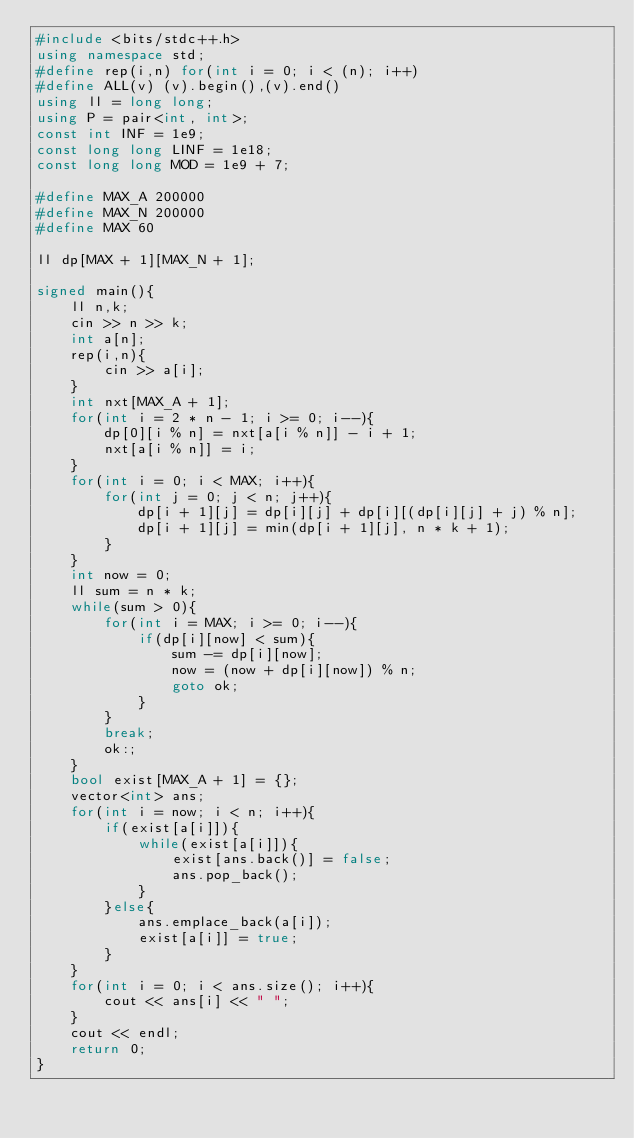Convert code to text. <code><loc_0><loc_0><loc_500><loc_500><_C++_>#include <bits/stdc++.h>
using namespace std;
#define rep(i,n) for(int i = 0; i < (n); i++)
#define ALL(v) (v).begin(),(v).end()
using ll = long long;
using P = pair<int, int>;
const int INF = 1e9;
const long long LINF = 1e18;
const long long MOD = 1e9 + 7;

#define MAX_A 200000
#define MAX_N 200000
#define MAX 60

ll dp[MAX + 1][MAX_N + 1];

signed main(){
    ll n,k;
    cin >> n >> k;
    int a[n];
    rep(i,n){
        cin >> a[i];
    }
    int nxt[MAX_A + 1];
    for(int i = 2 * n - 1; i >= 0; i--){
        dp[0][i % n] = nxt[a[i % n]] - i + 1;
        nxt[a[i % n]] = i;
    }
    for(int i = 0; i < MAX; i++){
        for(int j = 0; j < n; j++){
            dp[i + 1][j] = dp[i][j] + dp[i][(dp[i][j] + j) % n];
            dp[i + 1][j] = min(dp[i + 1][j], n * k + 1);
        }
    }
    int now = 0;
    ll sum = n * k;
    while(sum > 0){
        for(int i = MAX; i >= 0; i--){
            if(dp[i][now] < sum){
                sum -= dp[i][now];
                now = (now + dp[i][now]) % n;
                goto ok;
            }
        }
        break;
        ok:;
    }
    bool exist[MAX_A + 1] = {};
    vector<int> ans;
    for(int i = now; i < n; i++){
        if(exist[a[i]]){
            while(exist[a[i]]){
                exist[ans.back()] = false;
                ans.pop_back();
            }
        }else{
            ans.emplace_back(a[i]);
            exist[a[i]] = true;
        }
    }
    for(int i = 0; i < ans.size(); i++){
        cout << ans[i] << " ";
    }
    cout << endl;
    return 0;
}</code> 